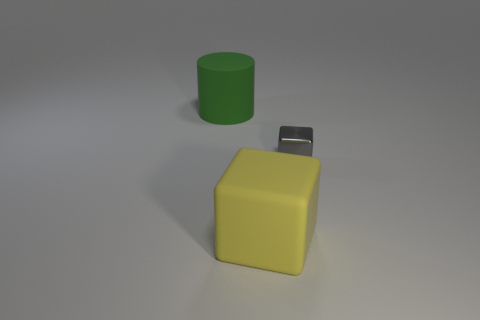Are the big thing right of the big green thing and the green cylinder made of the same material?
Give a very brief answer. Yes. Are any tiny shiny cubes visible?
Offer a terse response. Yes. Are there any yellow blocks made of the same material as the big green object?
Your answer should be compact. Yes. What is the color of the shiny thing?
Provide a short and direct response. Gray. What size is the gray metallic object in front of the matte thing that is behind the matte object in front of the cylinder?
Keep it short and to the point. Small. What number of other things are the same shape as the metal thing?
Provide a succinct answer. 1. There is a object that is both on the left side of the metal thing and in front of the large green rubber cylinder; what color is it?
Offer a very short reply. Yellow. Are there any other things that have the same size as the gray metal thing?
Offer a very short reply. No. How many cubes are either large yellow rubber objects or tiny metallic things?
Make the answer very short. 2. There is a big object in front of the large cylinder; what shape is it?
Ensure brevity in your answer.  Cube. 